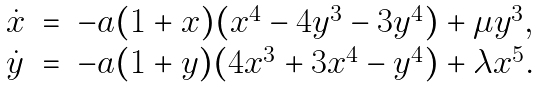<formula> <loc_0><loc_0><loc_500><loc_500>\begin{array} { l l l } \dot { x } & = & - a ( 1 + x ) ( x ^ { 4 } - 4 y ^ { 3 } - 3 y ^ { 4 } ) + \mu y ^ { 3 } , \\ \dot { y } & = & - a ( 1 + y ) ( 4 x ^ { 3 } + 3 x ^ { 4 } - y ^ { 4 } ) + \lambda x ^ { 5 } . \end{array}</formula> 